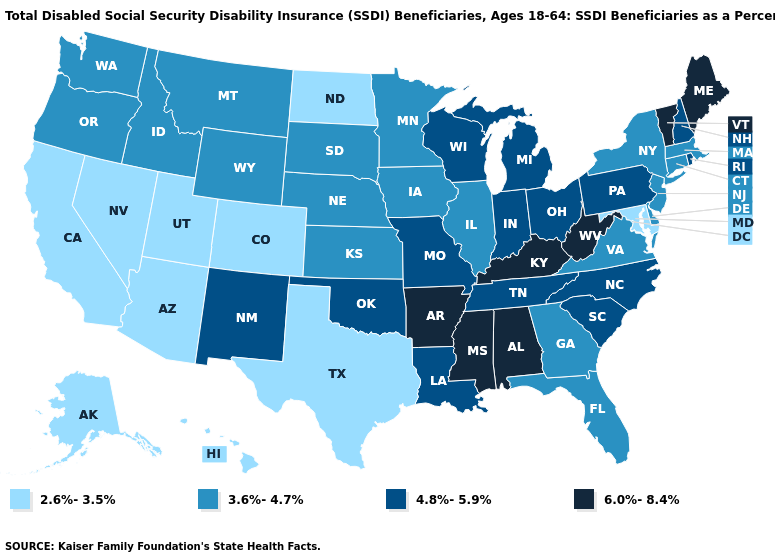What is the highest value in states that border Maryland?
Give a very brief answer. 6.0%-8.4%. Name the states that have a value in the range 2.6%-3.5%?
Write a very short answer. Alaska, Arizona, California, Colorado, Hawaii, Maryland, Nevada, North Dakota, Texas, Utah. What is the value of Oregon?
Quick response, please. 3.6%-4.7%. Does the map have missing data?
Concise answer only. No. Name the states that have a value in the range 3.6%-4.7%?
Be succinct. Connecticut, Delaware, Florida, Georgia, Idaho, Illinois, Iowa, Kansas, Massachusetts, Minnesota, Montana, Nebraska, New Jersey, New York, Oregon, South Dakota, Virginia, Washington, Wyoming. Name the states that have a value in the range 3.6%-4.7%?
Answer briefly. Connecticut, Delaware, Florida, Georgia, Idaho, Illinois, Iowa, Kansas, Massachusetts, Minnesota, Montana, Nebraska, New Jersey, New York, Oregon, South Dakota, Virginia, Washington, Wyoming. Among the states that border Alabama , which have the lowest value?
Give a very brief answer. Florida, Georgia. Name the states that have a value in the range 2.6%-3.5%?
Write a very short answer. Alaska, Arizona, California, Colorado, Hawaii, Maryland, Nevada, North Dakota, Texas, Utah. Name the states that have a value in the range 4.8%-5.9%?
Keep it brief. Indiana, Louisiana, Michigan, Missouri, New Hampshire, New Mexico, North Carolina, Ohio, Oklahoma, Pennsylvania, Rhode Island, South Carolina, Tennessee, Wisconsin. Does Montana have a higher value than Texas?
Keep it brief. Yes. Name the states that have a value in the range 3.6%-4.7%?
Short answer required. Connecticut, Delaware, Florida, Georgia, Idaho, Illinois, Iowa, Kansas, Massachusetts, Minnesota, Montana, Nebraska, New Jersey, New York, Oregon, South Dakota, Virginia, Washington, Wyoming. What is the value of Maryland?
Write a very short answer. 2.6%-3.5%. Does the first symbol in the legend represent the smallest category?
Keep it brief. Yes. Among the states that border Minnesota , which have the highest value?
Keep it brief. Wisconsin. What is the highest value in states that border Washington?
Give a very brief answer. 3.6%-4.7%. 